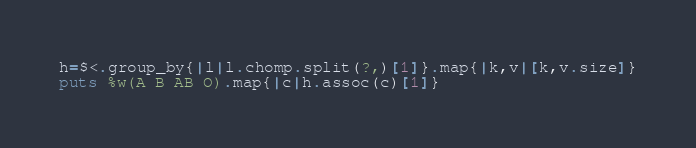<code> <loc_0><loc_0><loc_500><loc_500><_Ruby_>h=$<.group_by{|l|l.chomp.split(?,)[1]}.map{|k,v|[k,v.size]}
puts %w(A B AB O).map{|c|h.assoc(c)[1]}</code> 